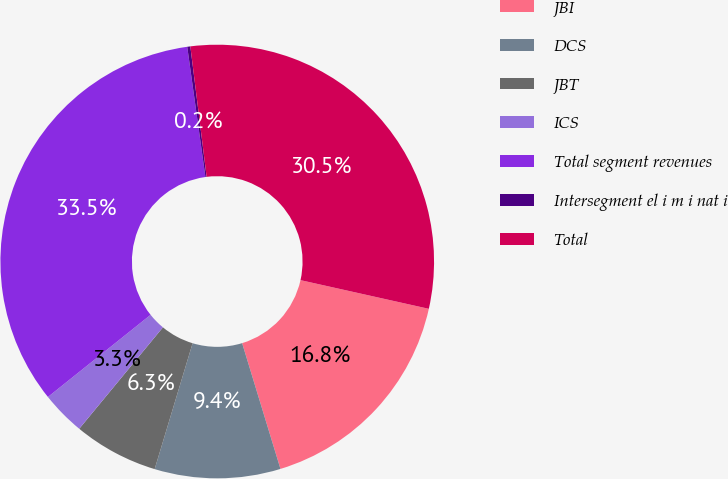<chart> <loc_0><loc_0><loc_500><loc_500><pie_chart><fcel>JBI<fcel>DCS<fcel>JBT<fcel>ICS<fcel>Total segment revenues<fcel>Intersegment el i m i nat i<fcel>Total<nl><fcel>16.79%<fcel>9.37%<fcel>6.32%<fcel>3.28%<fcel>33.53%<fcel>0.23%<fcel>30.48%<nl></chart> 